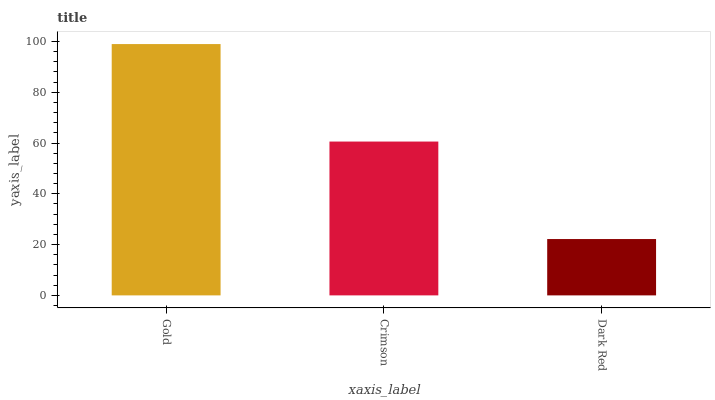Is Dark Red the minimum?
Answer yes or no. Yes. Is Gold the maximum?
Answer yes or no. Yes. Is Crimson the minimum?
Answer yes or no. No. Is Crimson the maximum?
Answer yes or no. No. Is Gold greater than Crimson?
Answer yes or no. Yes. Is Crimson less than Gold?
Answer yes or no. Yes. Is Crimson greater than Gold?
Answer yes or no. No. Is Gold less than Crimson?
Answer yes or no. No. Is Crimson the high median?
Answer yes or no. Yes. Is Crimson the low median?
Answer yes or no. Yes. Is Dark Red the high median?
Answer yes or no. No. Is Gold the low median?
Answer yes or no. No. 